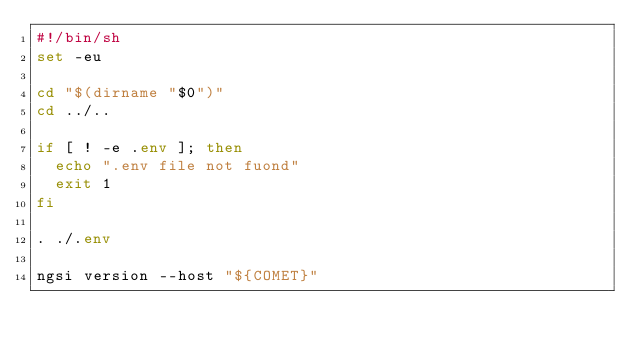<code> <loc_0><loc_0><loc_500><loc_500><_Bash_>#!/bin/sh
set -eu

cd "$(dirname "$0")"
cd ../..

if [ ! -e .env ]; then
  echo ".env file not fuond"
  exit 1
fi

. ./.env

ngsi version --host "${COMET}"
</code> 